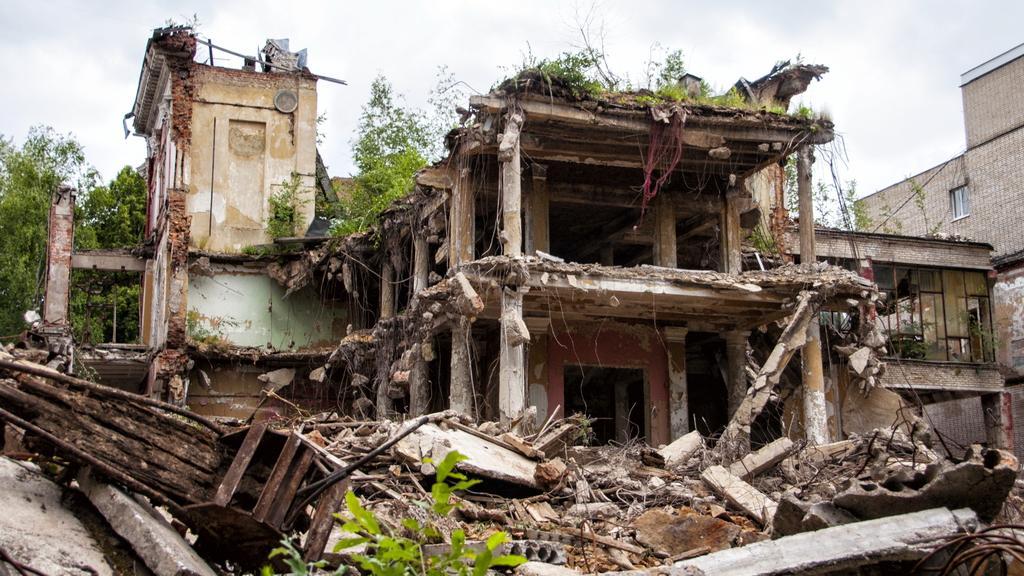In one or two sentences, can you explain what this image depicts? There are many collapsed buildings. In the back there are trees and sky. There are pillars and iron rods. 